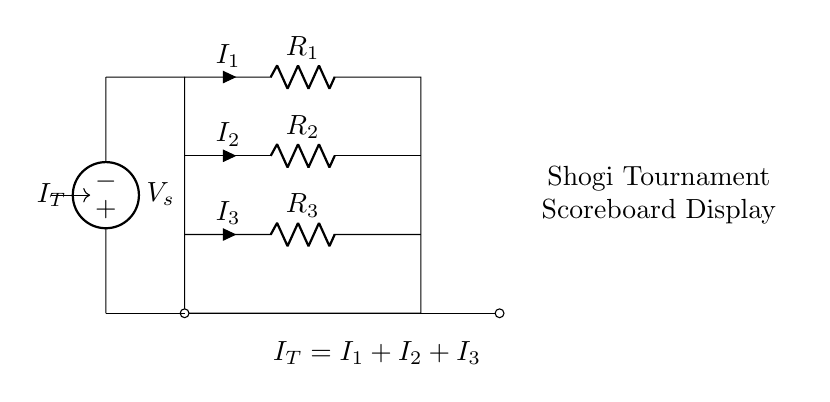What is the total current entering the circuit? The total current entering the circuit, denoted as IT, is the sum of the currents through each resistor (I1, I2, I3). This relationship is given in the circuit diagram, where IT = I1 + I2 + I3.
Answer: IT What is the function of the voltage source in this circuit? The voltage source, labeled as Vs, provides the electrical potential difference that drives the current through the resistor network. It establishes the total potential across the circuit that interacts with the resistors.
Answer: Provide potential How many resistors are in the circuit? There are three resistors labeled R1, R2, and R3 in the circuit diagram. Each acts to divide the total current IT based on their resistances.
Answer: Three What type of circuit is represented by this diagram? The diagram represents a parallel resistor network, where multiple resistors are connected in parallel to share the total current among them.
Answer: Parallel How does the current divide among the resistors? The current diverts among the resistors according to their resistances; lower resistance allows more current to pass, while higher resistance allows less. This is a principle of the current divider rule.
Answer: Based on resistance What do the labels I1, I2, and I3 indicate? The labels I1, I2, and I3 represent the individual currents flowing through resistors R1, R2, and R3, respectively. Each current is a fraction of the total current IT depending on the resistors' values.
Answer: Individual currents 